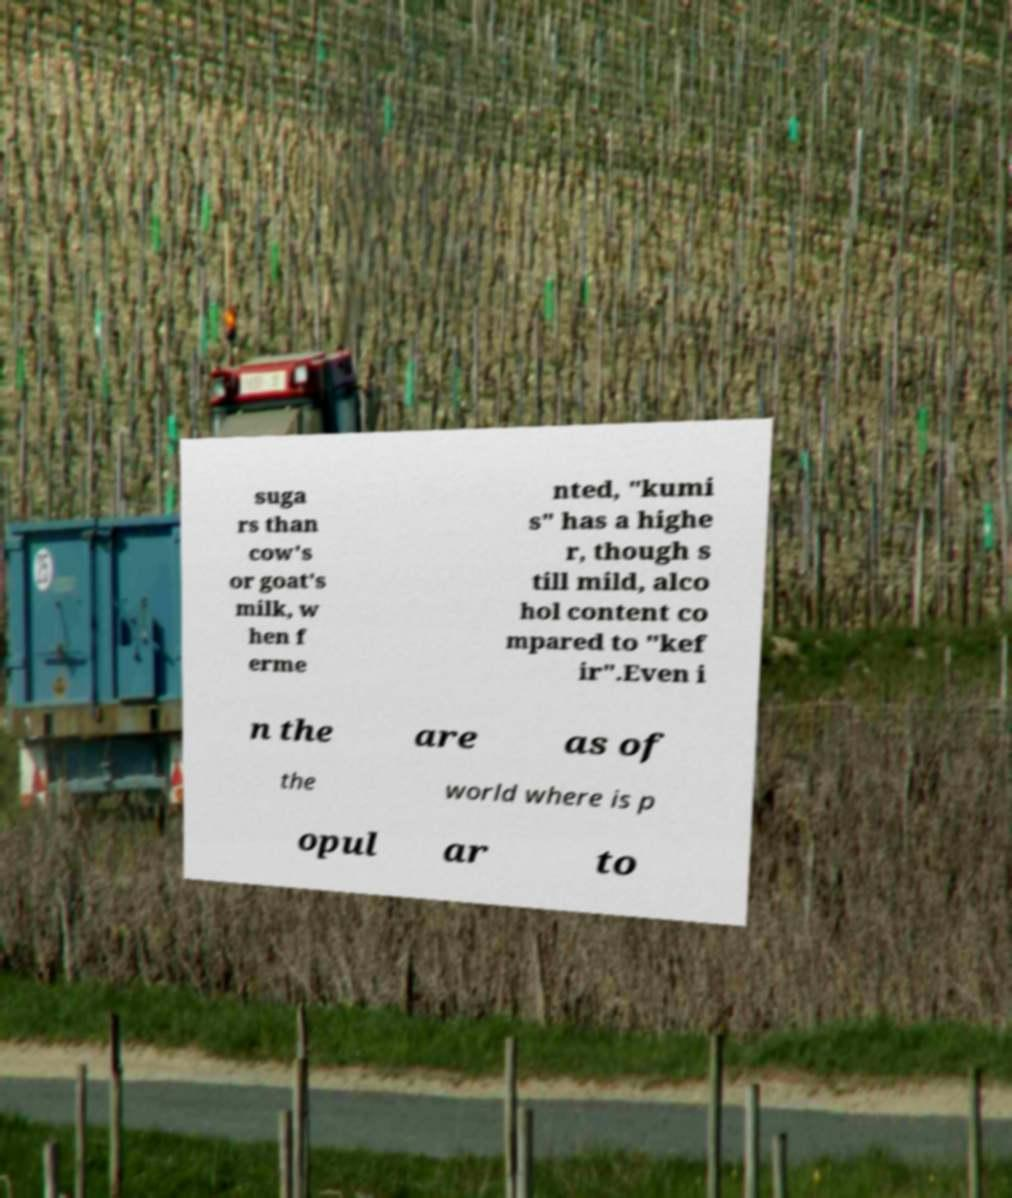Can you read and provide the text displayed in the image?This photo seems to have some interesting text. Can you extract and type it out for me? suga rs than cow's or goat's milk, w hen f erme nted, "kumi s" has a highe r, though s till mild, alco hol content co mpared to "kef ir".Even i n the are as of the world where is p opul ar to 